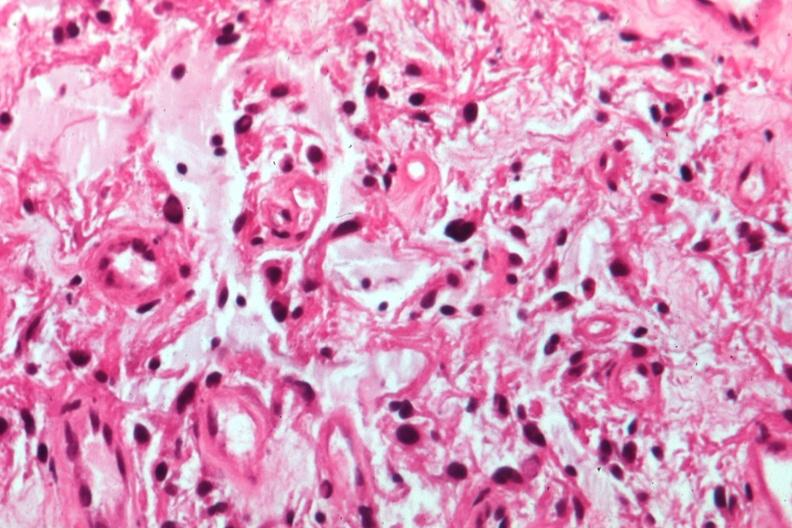what is present?
Answer the question using a single word or phrase. Optic nerve 